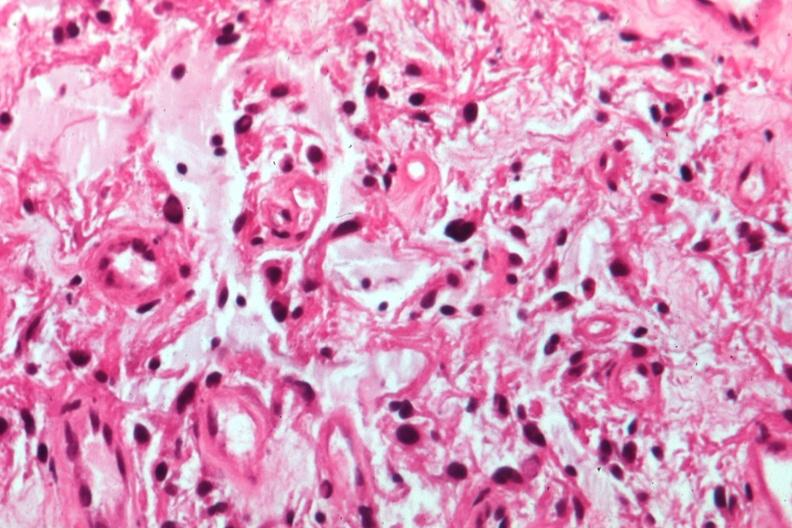what is present?
Answer the question using a single word or phrase. Optic nerve 